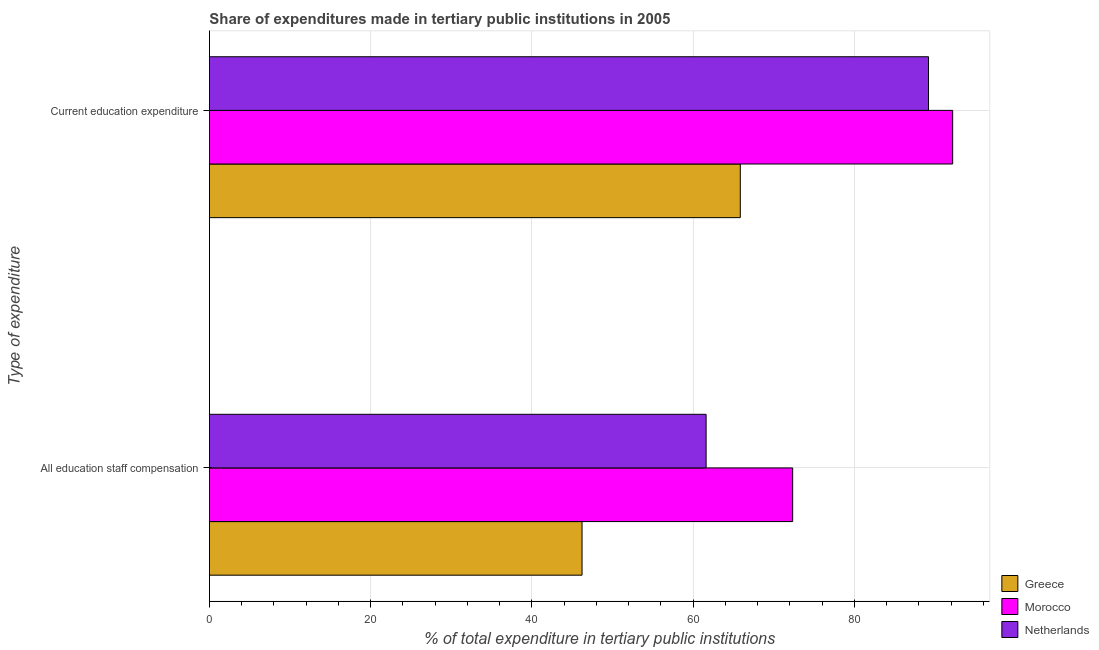How many groups of bars are there?
Your response must be concise. 2. Are the number of bars per tick equal to the number of legend labels?
Make the answer very short. Yes. Are the number of bars on each tick of the Y-axis equal?
Offer a terse response. Yes. What is the label of the 2nd group of bars from the top?
Give a very brief answer. All education staff compensation. What is the expenditure in staff compensation in Morocco?
Your answer should be compact. 72.34. Across all countries, what is the maximum expenditure in staff compensation?
Make the answer very short. 72.34. Across all countries, what is the minimum expenditure in education?
Your answer should be compact. 65.84. In which country was the expenditure in staff compensation maximum?
Give a very brief answer. Morocco. What is the total expenditure in staff compensation in the graph?
Offer a terse response. 180.16. What is the difference between the expenditure in education in Greece and that in Morocco?
Provide a succinct answer. -26.34. What is the difference between the expenditure in education in Morocco and the expenditure in staff compensation in Greece?
Offer a terse response. 45.97. What is the average expenditure in education per country?
Give a very brief answer. 82.4. What is the difference between the expenditure in staff compensation and expenditure in education in Morocco?
Offer a very short reply. -19.84. In how many countries, is the expenditure in education greater than 4 %?
Give a very brief answer. 3. What is the ratio of the expenditure in education in Netherlands to that in Greece?
Your response must be concise. 1.35. What does the 2nd bar from the top in Current education expenditure represents?
Provide a succinct answer. Morocco. What does the 2nd bar from the bottom in All education staff compensation represents?
Offer a very short reply. Morocco. How many bars are there?
Offer a terse response. 6. Are all the bars in the graph horizontal?
Offer a terse response. Yes. Does the graph contain grids?
Offer a terse response. Yes. How many legend labels are there?
Your answer should be very brief. 3. What is the title of the graph?
Keep it short and to the point. Share of expenditures made in tertiary public institutions in 2005. Does "Qatar" appear as one of the legend labels in the graph?
Offer a terse response. No. What is the label or title of the X-axis?
Offer a terse response. % of total expenditure in tertiary public institutions. What is the label or title of the Y-axis?
Your response must be concise. Type of expenditure. What is the % of total expenditure in tertiary public institutions of Greece in All education staff compensation?
Ensure brevity in your answer.  46.22. What is the % of total expenditure in tertiary public institutions in Morocco in All education staff compensation?
Your response must be concise. 72.34. What is the % of total expenditure in tertiary public institutions in Netherlands in All education staff compensation?
Your response must be concise. 61.6. What is the % of total expenditure in tertiary public institutions of Greece in Current education expenditure?
Give a very brief answer. 65.84. What is the % of total expenditure in tertiary public institutions in Morocco in Current education expenditure?
Provide a succinct answer. 92.18. What is the % of total expenditure in tertiary public institutions in Netherlands in Current education expenditure?
Provide a short and direct response. 89.19. Across all Type of expenditure, what is the maximum % of total expenditure in tertiary public institutions of Greece?
Ensure brevity in your answer.  65.84. Across all Type of expenditure, what is the maximum % of total expenditure in tertiary public institutions of Morocco?
Give a very brief answer. 92.18. Across all Type of expenditure, what is the maximum % of total expenditure in tertiary public institutions of Netherlands?
Ensure brevity in your answer.  89.19. Across all Type of expenditure, what is the minimum % of total expenditure in tertiary public institutions of Greece?
Your response must be concise. 46.22. Across all Type of expenditure, what is the minimum % of total expenditure in tertiary public institutions in Morocco?
Keep it short and to the point. 72.34. Across all Type of expenditure, what is the minimum % of total expenditure in tertiary public institutions of Netherlands?
Keep it short and to the point. 61.6. What is the total % of total expenditure in tertiary public institutions in Greece in the graph?
Provide a short and direct response. 112.06. What is the total % of total expenditure in tertiary public institutions in Morocco in the graph?
Your answer should be very brief. 164.52. What is the total % of total expenditure in tertiary public institutions in Netherlands in the graph?
Keep it short and to the point. 150.79. What is the difference between the % of total expenditure in tertiary public institutions in Greece in All education staff compensation and that in Current education expenditure?
Make the answer very short. -19.63. What is the difference between the % of total expenditure in tertiary public institutions of Morocco in All education staff compensation and that in Current education expenditure?
Provide a succinct answer. -19.84. What is the difference between the % of total expenditure in tertiary public institutions of Netherlands in All education staff compensation and that in Current education expenditure?
Provide a short and direct response. -27.58. What is the difference between the % of total expenditure in tertiary public institutions of Greece in All education staff compensation and the % of total expenditure in tertiary public institutions of Morocco in Current education expenditure?
Provide a short and direct response. -45.97. What is the difference between the % of total expenditure in tertiary public institutions of Greece in All education staff compensation and the % of total expenditure in tertiary public institutions of Netherlands in Current education expenditure?
Keep it short and to the point. -42.97. What is the difference between the % of total expenditure in tertiary public institutions in Morocco in All education staff compensation and the % of total expenditure in tertiary public institutions in Netherlands in Current education expenditure?
Ensure brevity in your answer.  -16.85. What is the average % of total expenditure in tertiary public institutions in Greece per Type of expenditure?
Your answer should be compact. 56.03. What is the average % of total expenditure in tertiary public institutions in Morocco per Type of expenditure?
Offer a terse response. 82.26. What is the average % of total expenditure in tertiary public institutions in Netherlands per Type of expenditure?
Give a very brief answer. 75.39. What is the difference between the % of total expenditure in tertiary public institutions in Greece and % of total expenditure in tertiary public institutions in Morocco in All education staff compensation?
Your answer should be compact. -26.12. What is the difference between the % of total expenditure in tertiary public institutions of Greece and % of total expenditure in tertiary public institutions of Netherlands in All education staff compensation?
Keep it short and to the point. -15.39. What is the difference between the % of total expenditure in tertiary public institutions of Morocco and % of total expenditure in tertiary public institutions of Netherlands in All education staff compensation?
Make the answer very short. 10.74. What is the difference between the % of total expenditure in tertiary public institutions of Greece and % of total expenditure in tertiary public institutions of Morocco in Current education expenditure?
Your response must be concise. -26.34. What is the difference between the % of total expenditure in tertiary public institutions in Greece and % of total expenditure in tertiary public institutions in Netherlands in Current education expenditure?
Your response must be concise. -23.34. What is the difference between the % of total expenditure in tertiary public institutions of Morocco and % of total expenditure in tertiary public institutions of Netherlands in Current education expenditure?
Provide a succinct answer. 3. What is the ratio of the % of total expenditure in tertiary public institutions in Greece in All education staff compensation to that in Current education expenditure?
Offer a very short reply. 0.7. What is the ratio of the % of total expenditure in tertiary public institutions in Morocco in All education staff compensation to that in Current education expenditure?
Give a very brief answer. 0.78. What is the ratio of the % of total expenditure in tertiary public institutions in Netherlands in All education staff compensation to that in Current education expenditure?
Make the answer very short. 0.69. What is the difference between the highest and the second highest % of total expenditure in tertiary public institutions of Greece?
Give a very brief answer. 19.63. What is the difference between the highest and the second highest % of total expenditure in tertiary public institutions in Morocco?
Offer a very short reply. 19.84. What is the difference between the highest and the second highest % of total expenditure in tertiary public institutions in Netherlands?
Provide a succinct answer. 27.58. What is the difference between the highest and the lowest % of total expenditure in tertiary public institutions in Greece?
Give a very brief answer. 19.63. What is the difference between the highest and the lowest % of total expenditure in tertiary public institutions in Morocco?
Your answer should be compact. 19.84. What is the difference between the highest and the lowest % of total expenditure in tertiary public institutions of Netherlands?
Make the answer very short. 27.58. 